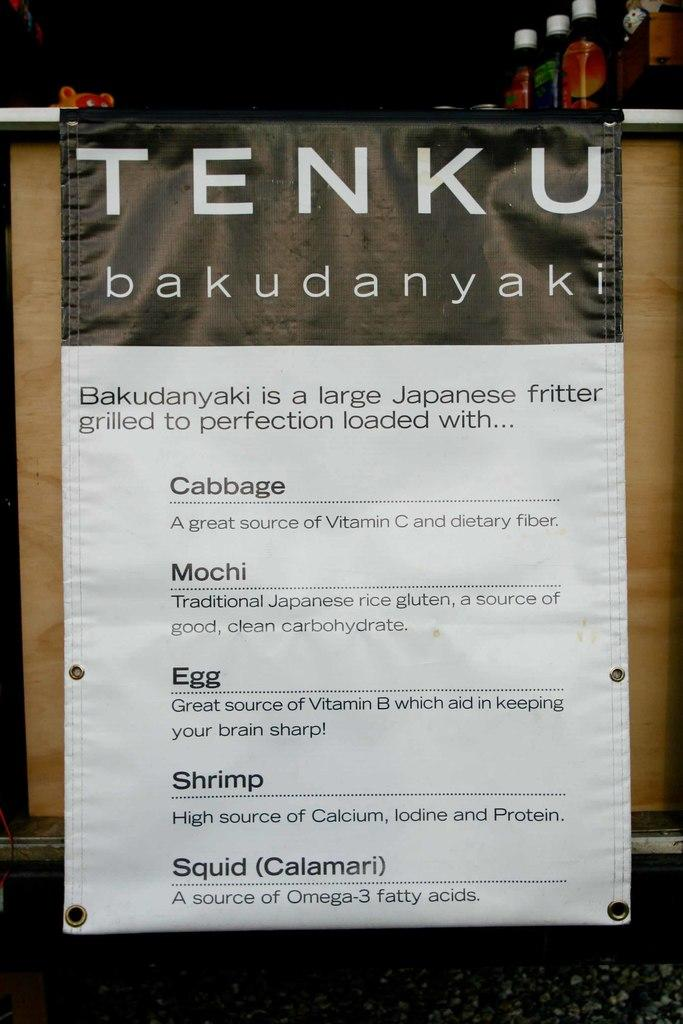What piece of furniture is present in the image? There is a table in the image. What objects are placed on the table? Bottles are placed on the table. What is hanging near the table? There is a banner hanging near the table. What can be found on the banner? Text is printed on the banner. What type of rice is being served on the table in the image? There is no rice present in the image; the objects on the table are bottles. 